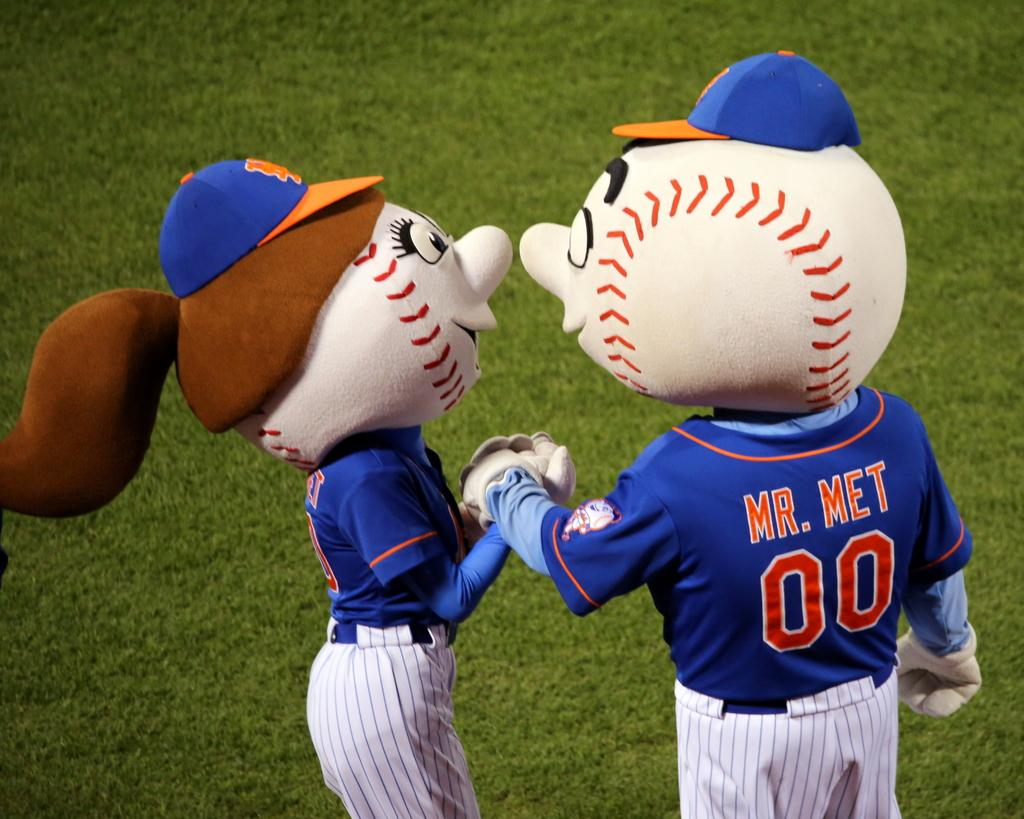<image>
Provide a brief description of the given image. Baseball mascots holding hands one is called Mr. Met. 